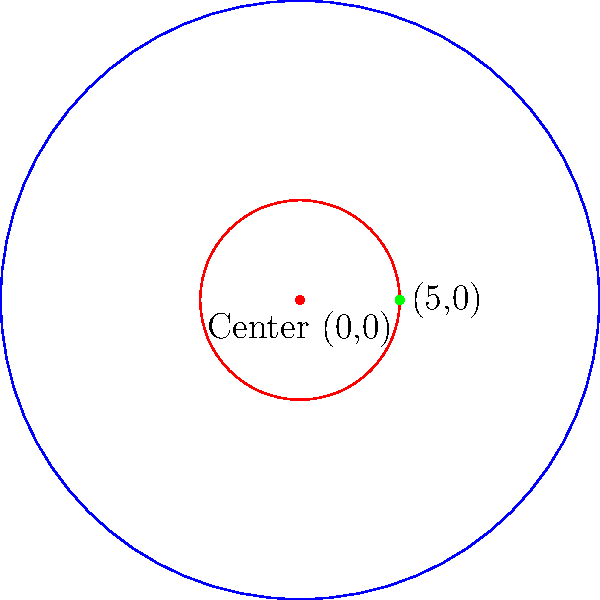In a regulation NHL rink, the face-off circle has a radius of 15 feet. If the center of the face-off circle is at the origin (0,0) and a point on the circle is at (5,0), what is the equation of the circle representing the face-off circle? To find the equation of the circle, we'll follow these steps:

1) The general equation of a circle is $(x-h)^2 + (y-k)^2 = r^2$, where (h,k) is the center and r is the radius.

2) We're given that the center is at (0,0), so h = 0 and k = 0.

3) We need to find the radius. We're told a point on the circle is at (5,0).

4) Using the distance formula:
   $r^2 = (x-h)^2 + (y-k)^2 = (5-0)^2 + (0-0)^2 = 25$

5) Therefore, $r = 5$

6) Substituting these values into the general equation:
   $(x-0)^2 + (y-0)^2 = 5^2$

7) Simplifying:
   $x^2 + y^2 = 25$

This is the equation of the face-off circle.
Answer: $x^2 + y^2 = 25$ 